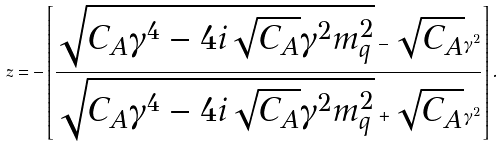<formula> <loc_0><loc_0><loc_500><loc_500>z = - \left [ \frac { \sqrt { C _ { A } \gamma ^ { 4 } - 4 i \sqrt { C _ { A } } \gamma ^ { 2 } m ^ { 2 } _ { q } } - \sqrt { C _ { A } } \gamma ^ { 2 } } { \sqrt { C _ { A } \gamma ^ { 4 } - 4 i \sqrt { C _ { A } } \gamma ^ { 2 } m ^ { 2 } _ { q } } + \sqrt { C _ { A } } \gamma ^ { 2 } } \right ] .</formula> 